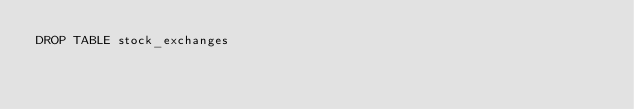<code> <loc_0><loc_0><loc_500><loc_500><_SQL_>DROP TABLE stock_exchanges
</code> 